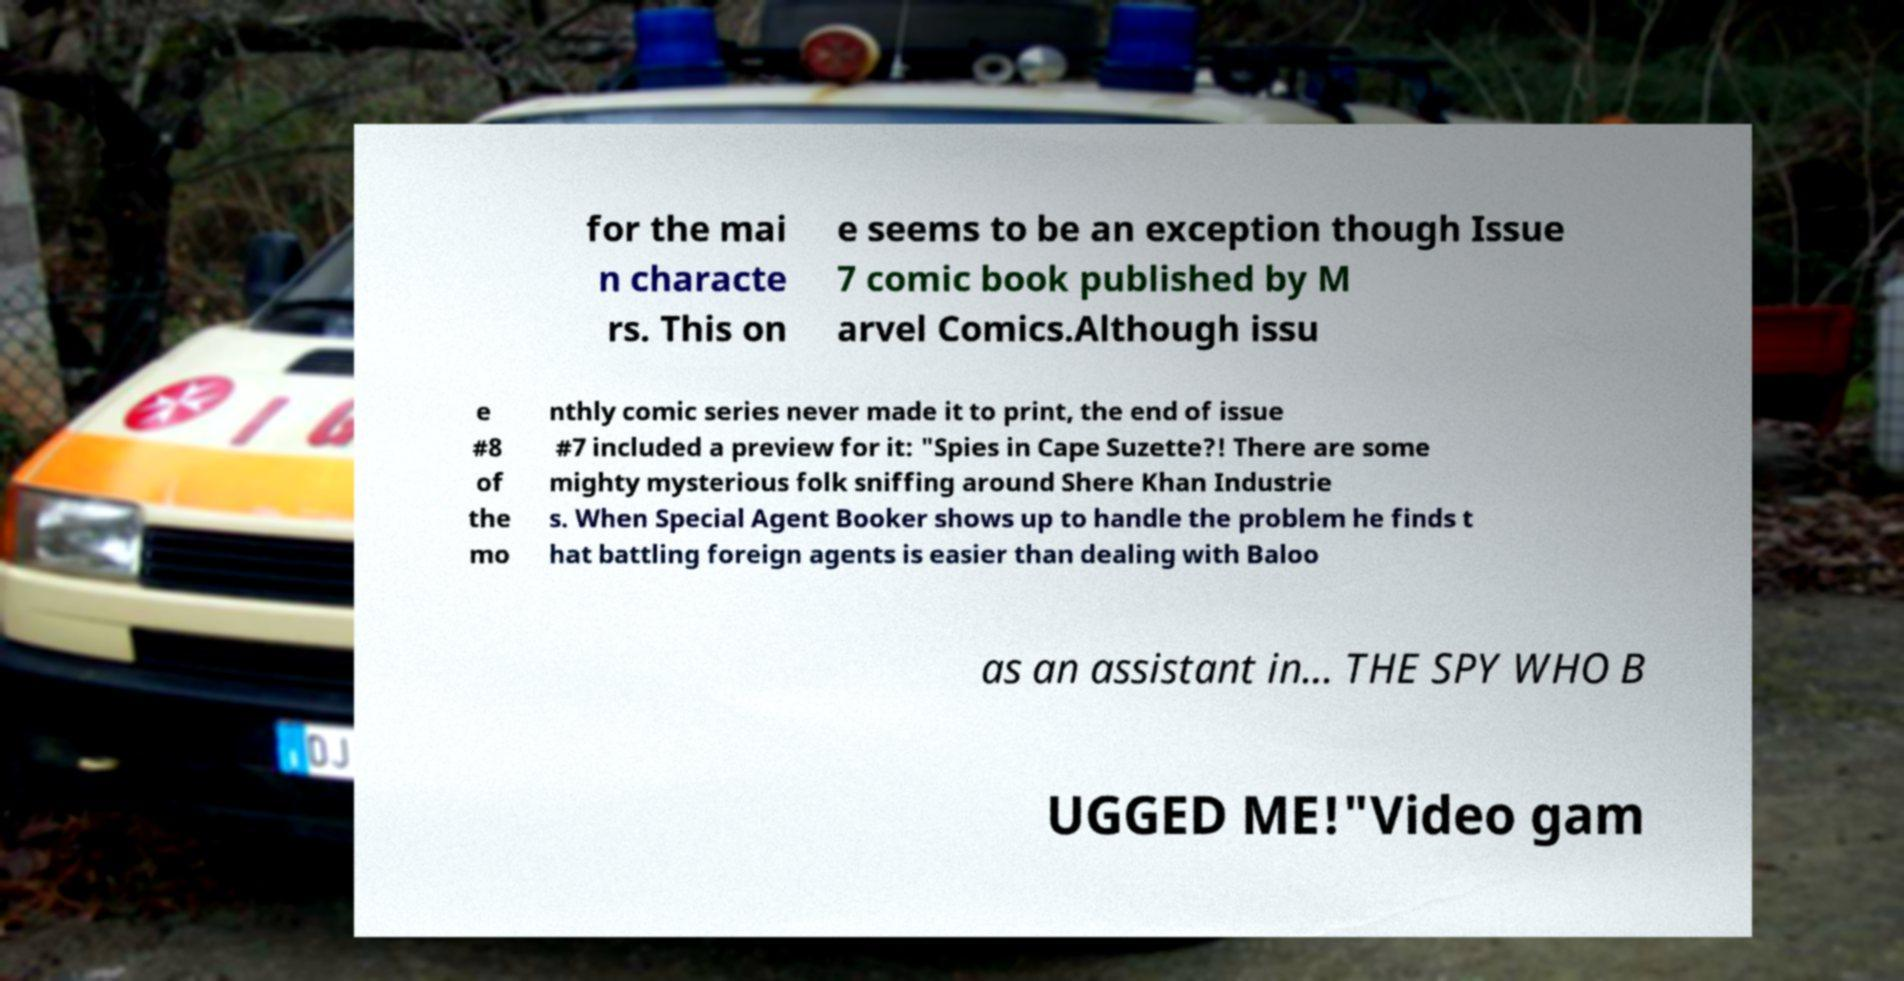For documentation purposes, I need the text within this image transcribed. Could you provide that? for the mai n characte rs. This on e seems to be an exception though Issue 7 comic book published by M arvel Comics.Although issu e #8 of the mo nthly comic series never made it to print, the end of issue #7 included a preview for it: "Spies in Cape Suzette?! There are some mighty mysterious folk sniffing around Shere Khan Industrie s. When Special Agent Booker shows up to handle the problem he finds t hat battling foreign agents is easier than dealing with Baloo as an assistant in... THE SPY WHO B UGGED ME!"Video gam 